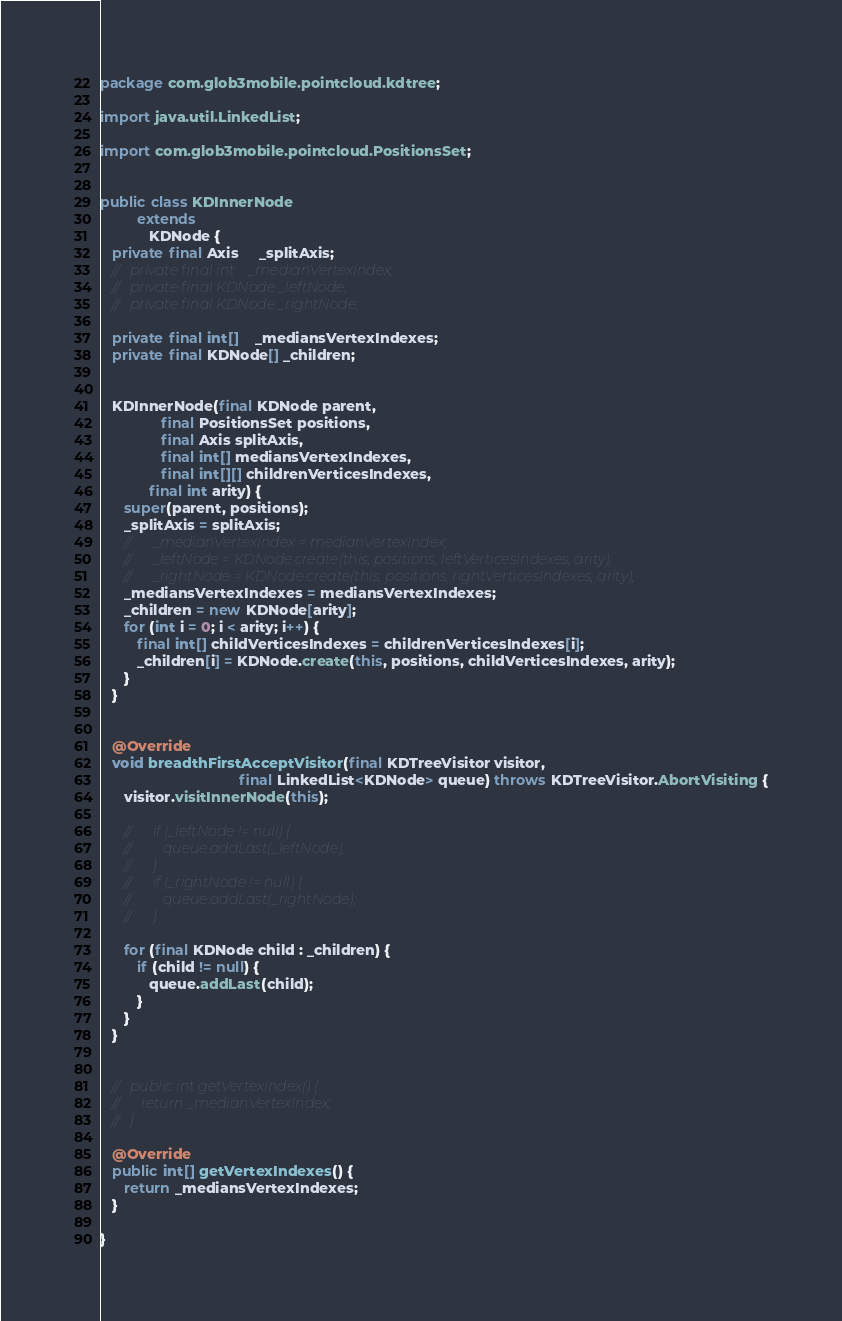Convert code to text. <code><loc_0><loc_0><loc_500><loc_500><_Java_>

package com.glob3mobile.pointcloud.kdtree;

import java.util.LinkedList;

import com.glob3mobile.pointcloud.PositionsSet;


public class KDInnerNode
         extends
            KDNode {
   private final Axis     _splitAxis;
   //   private final int    _medianVertexIndex;
   //   private final KDNode _leftNode;
   //   private final KDNode _rightNode;

   private final int[]    _mediansVertexIndexes;
   private final KDNode[] _children;


   KDInnerNode(final KDNode parent,
               final PositionsSet positions,
               final Axis splitAxis,
               final int[] mediansVertexIndexes,
               final int[][] childrenVerticesIndexes,
            final int arity) {
      super(parent, positions);
      _splitAxis = splitAxis;
      //      _medianVertexIndex = medianVertexIndex;
      //      _leftNode = KDNode.create(this, positions, leftVerticesIndexes, arity);
      //      _rightNode = KDNode.create(this, positions, rightVerticesIndexes, arity);
      _mediansVertexIndexes = mediansVertexIndexes;
      _children = new KDNode[arity];
      for (int i = 0; i < arity; i++) {
         final int[] childVerticesIndexes = childrenVerticesIndexes[i];
         _children[i] = KDNode.create(this, positions, childVerticesIndexes, arity);
      }
   }


   @Override
   void breadthFirstAcceptVisitor(final KDTreeVisitor visitor,
                                  final LinkedList<KDNode> queue) throws KDTreeVisitor.AbortVisiting {
      visitor.visitInnerNode(this);

      //      if (_leftNode != null) {
      //         queue.addLast(_leftNode);
      //      }
      //      if (_rightNode != null) {
      //         queue.addLast(_rightNode);
      //      }

      for (final KDNode child : _children) {
         if (child != null) {
            queue.addLast(child);
         }
      }
   }


   //   public int getVertexIndex() {
   //      return _medianVertexIndex;
   //   }

   @Override
   public int[] getVertexIndexes() {
      return _mediansVertexIndexes;
   }

}
</code> 